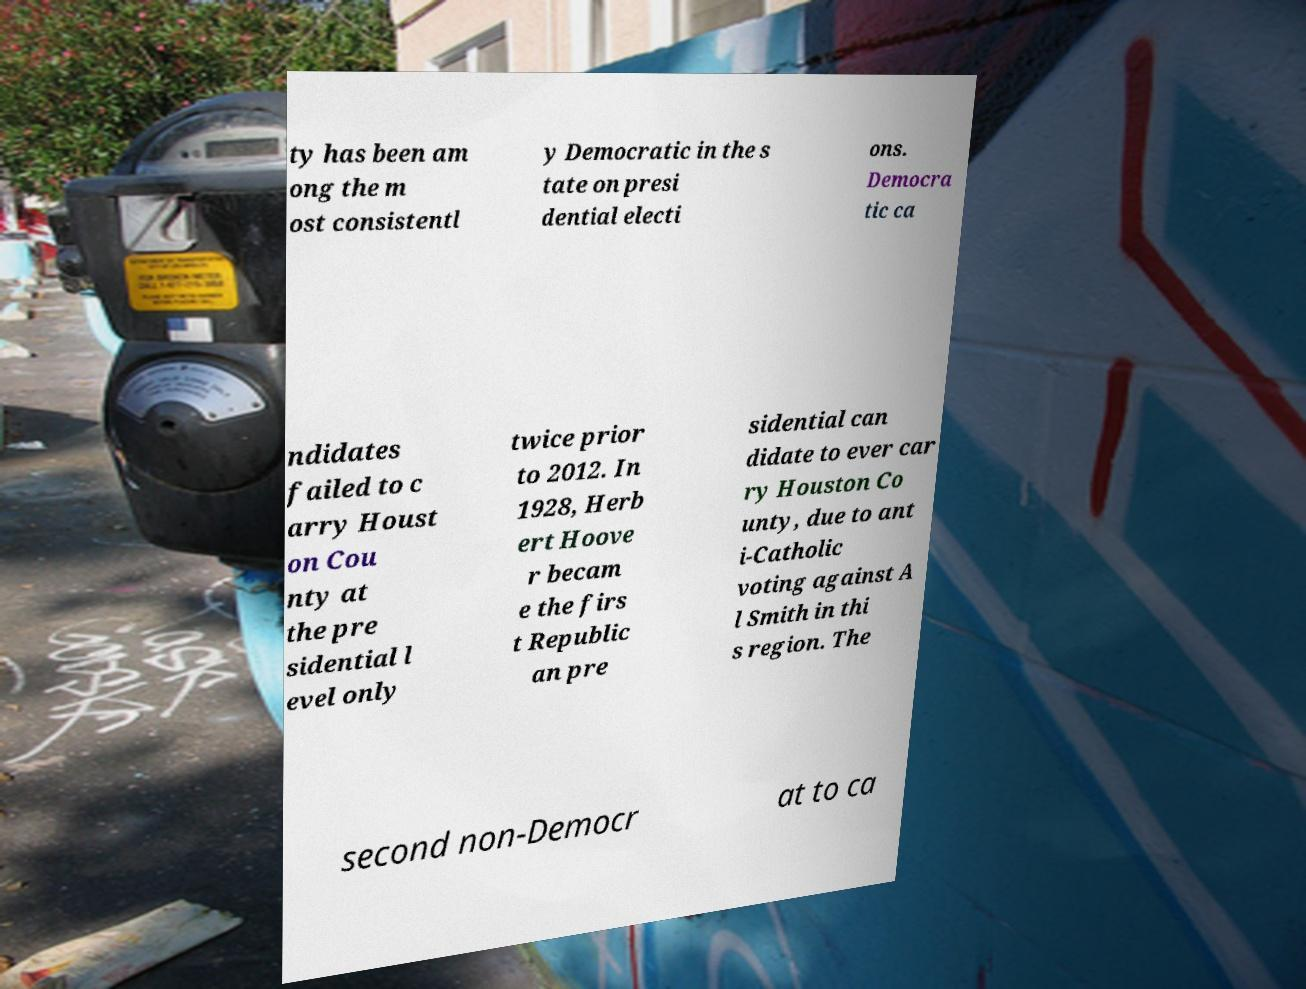Please identify and transcribe the text found in this image. ty has been am ong the m ost consistentl y Democratic in the s tate on presi dential electi ons. Democra tic ca ndidates failed to c arry Houst on Cou nty at the pre sidential l evel only twice prior to 2012. In 1928, Herb ert Hoove r becam e the firs t Republic an pre sidential can didate to ever car ry Houston Co unty, due to ant i-Catholic voting against A l Smith in thi s region. The second non-Democr at to ca 